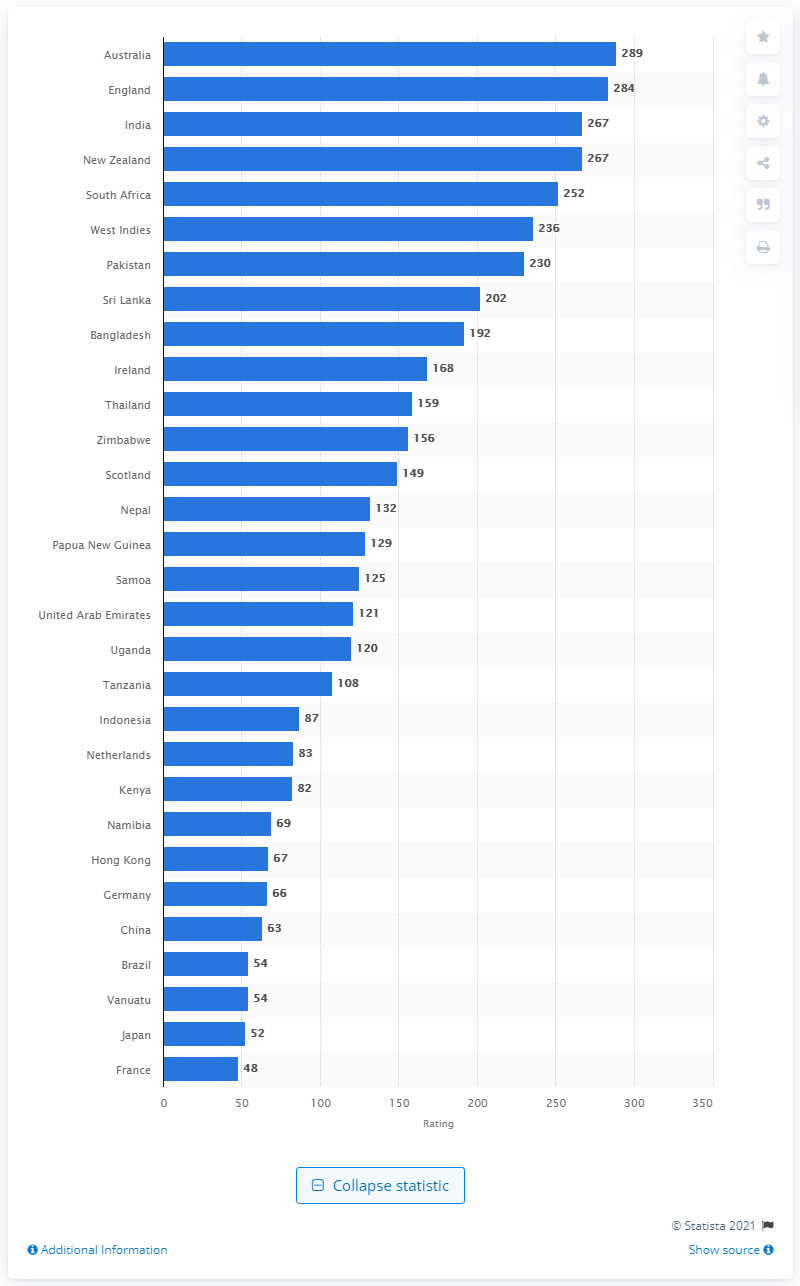Point out several critical features in this image. According to the latest rankings as of April 2021, Australia's rating for women's T20 nations is 289. 